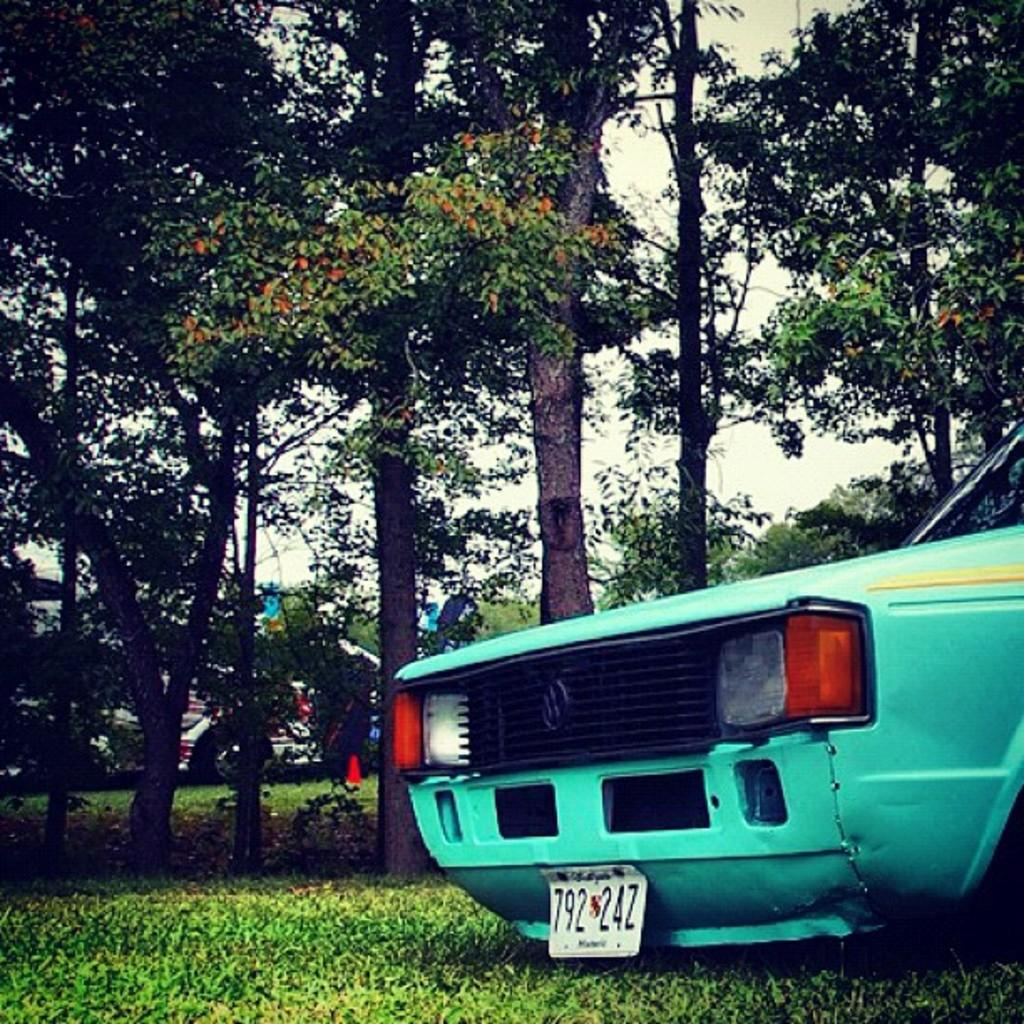What is located on the left side of the image? There is a car on the left side of the image. What type of vegetation can be seen in the image? There is grass in the image. What other natural elements are present in the image? There are trees in the image. What can be seen in the background of the image? There are vehicles visible in the background of the image. Where is the tent set up in the image? There is no tent present in the image. How many cars are parked in front of the home in the image? There is no home present in the image, and therefore no cars parked in front of it. 